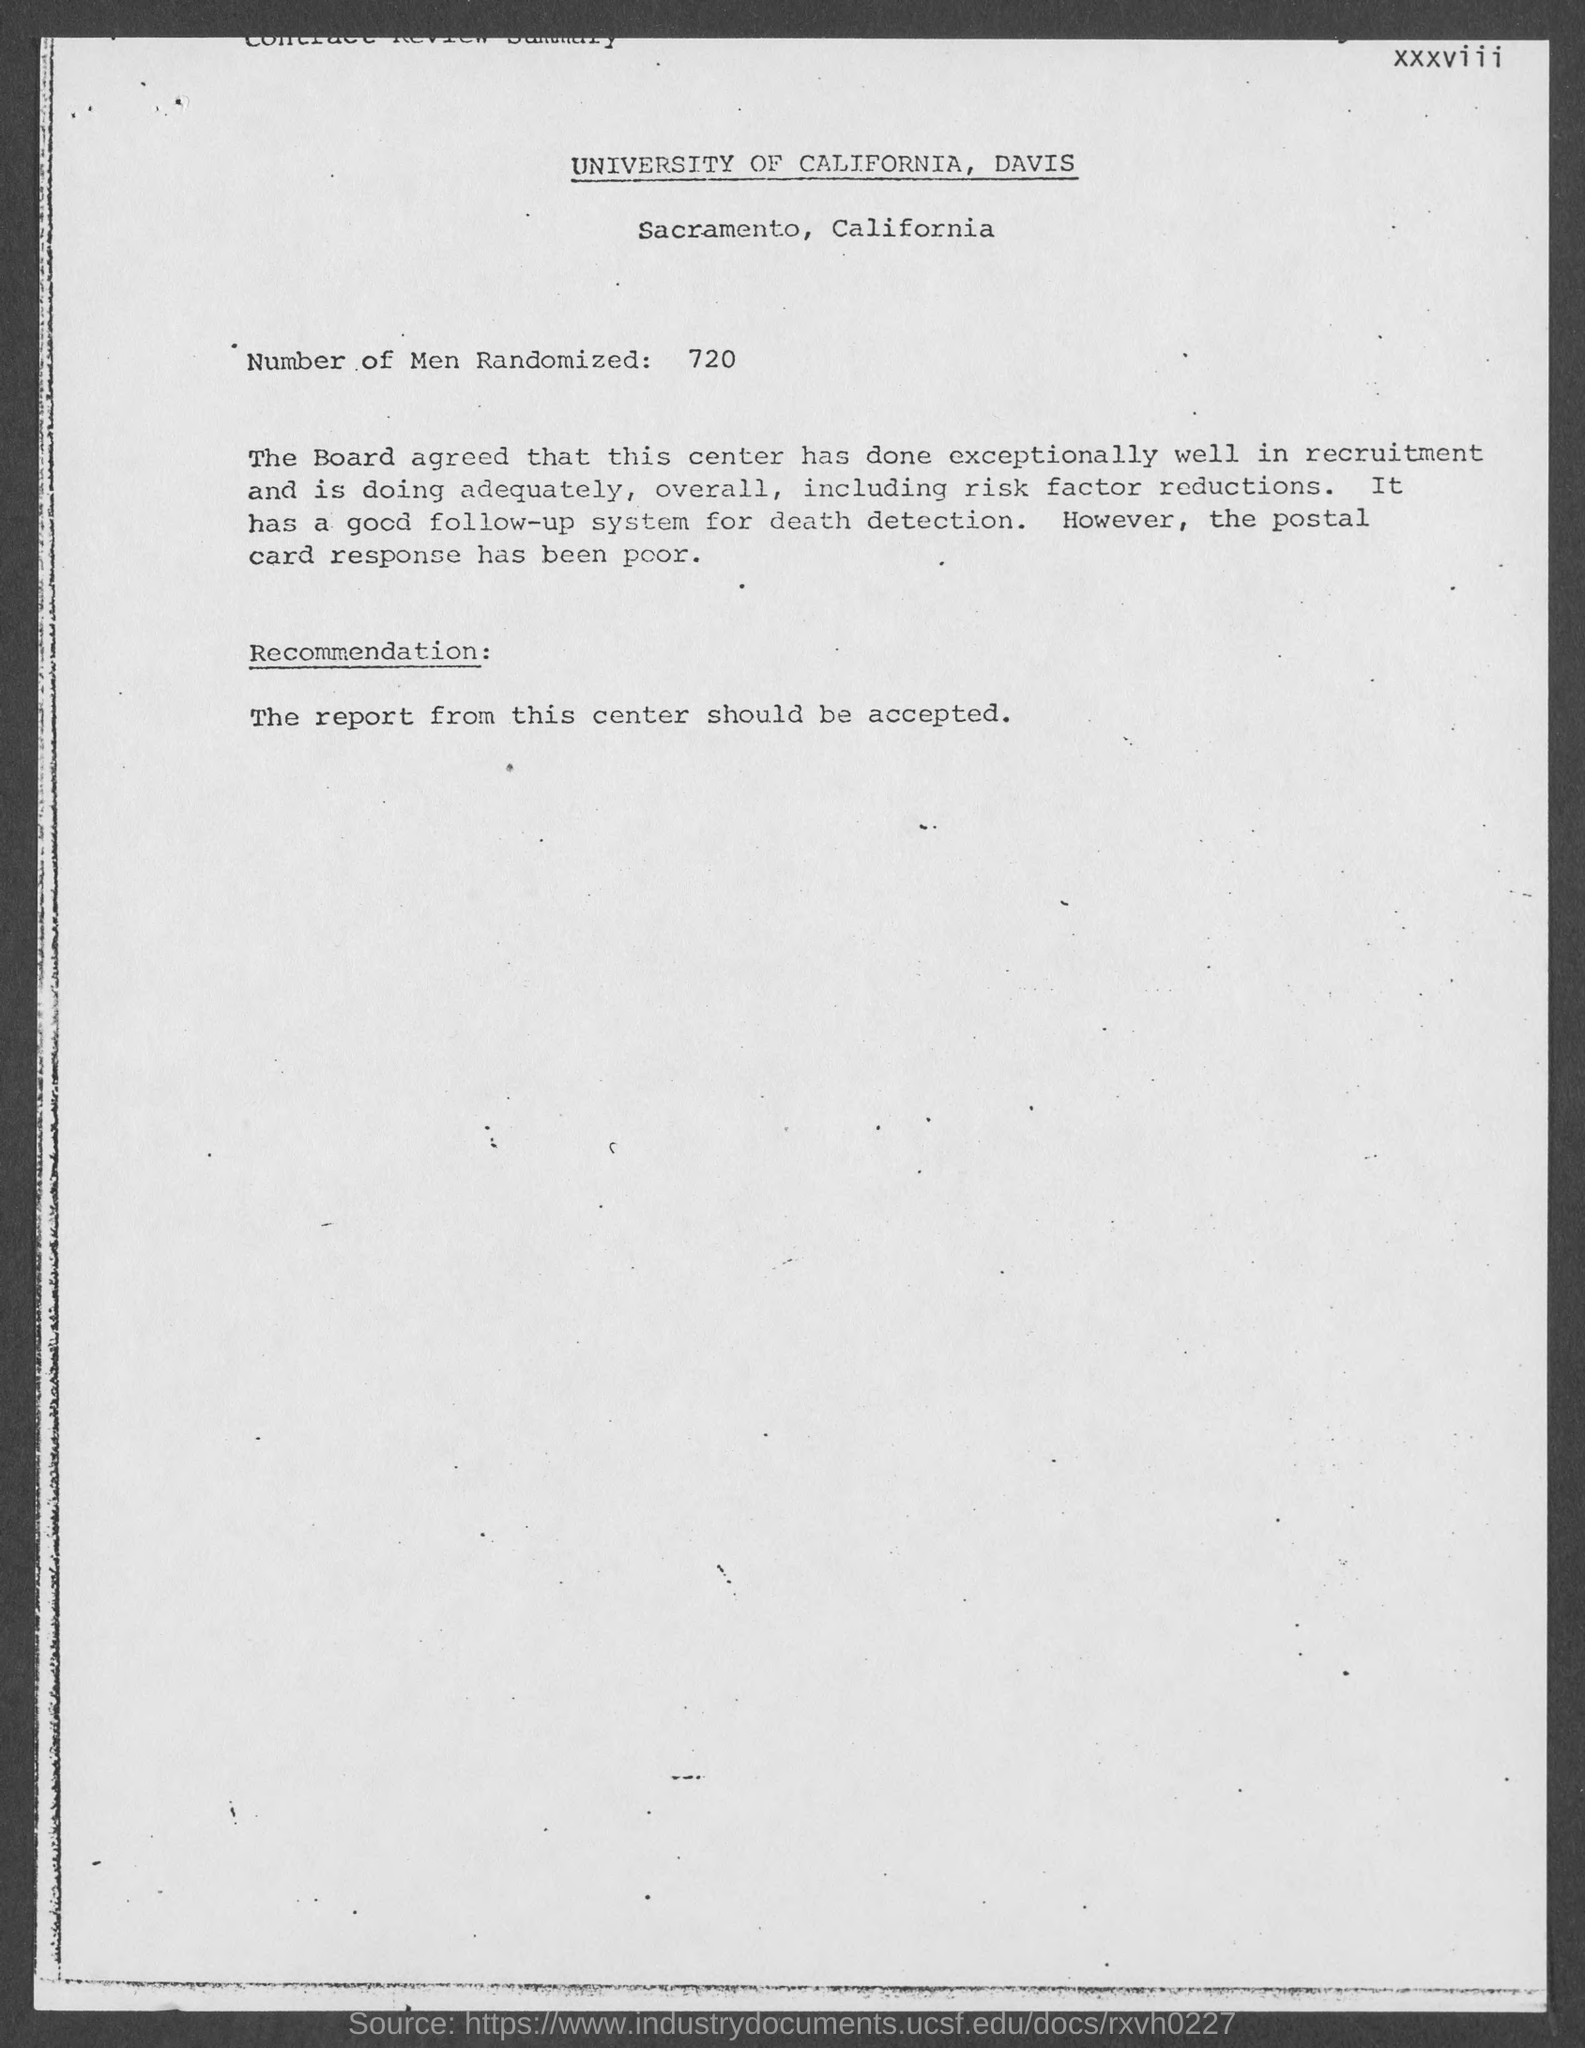How many number of men are randomized ?
Offer a terse response. 720. 